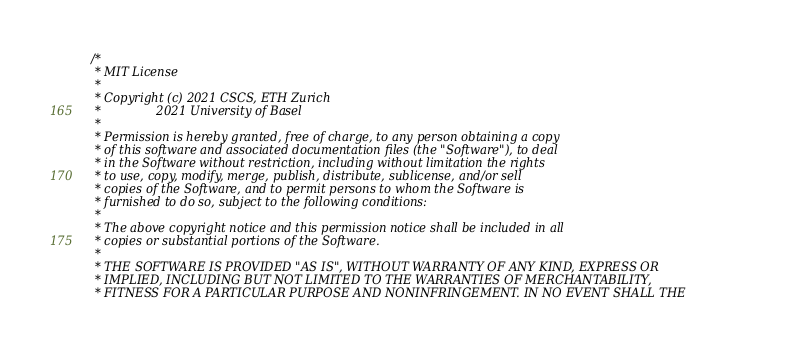Convert code to text. <code><loc_0><loc_0><loc_500><loc_500><_Cuda_>/*
 * MIT License
 *
 * Copyright (c) 2021 CSCS, ETH Zurich
 *               2021 University of Basel
 *
 * Permission is hereby granted, free of charge, to any person obtaining a copy
 * of this software and associated documentation files (the "Software"), to deal
 * in the Software without restriction, including without limitation the rights
 * to use, copy, modify, merge, publish, distribute, sublicense, and/or sell
 * copies of the Software, and to permit persons to whom the Software is
 * furnished to do so, subject to the following conditions:
 *
 * The above copyright notice and this permission notice shall be included in all
 * copies or substantial portions of the Software.
 *
 * THE SOFTWARE IS PROVIDED "AS IS", WITHOUT WARRANTY OF ANY KIND, EXPRESS OR
 * IMPLIED, INCLUDING BUT NOT LIMITED TO THE WARRANTIES OF MERCHANTABILITY,
 * FITNESS FOR A PARTICULAR PURPOSE AND NONINFRINGEMENT. IN NO EVENT SHALL THE</code> 